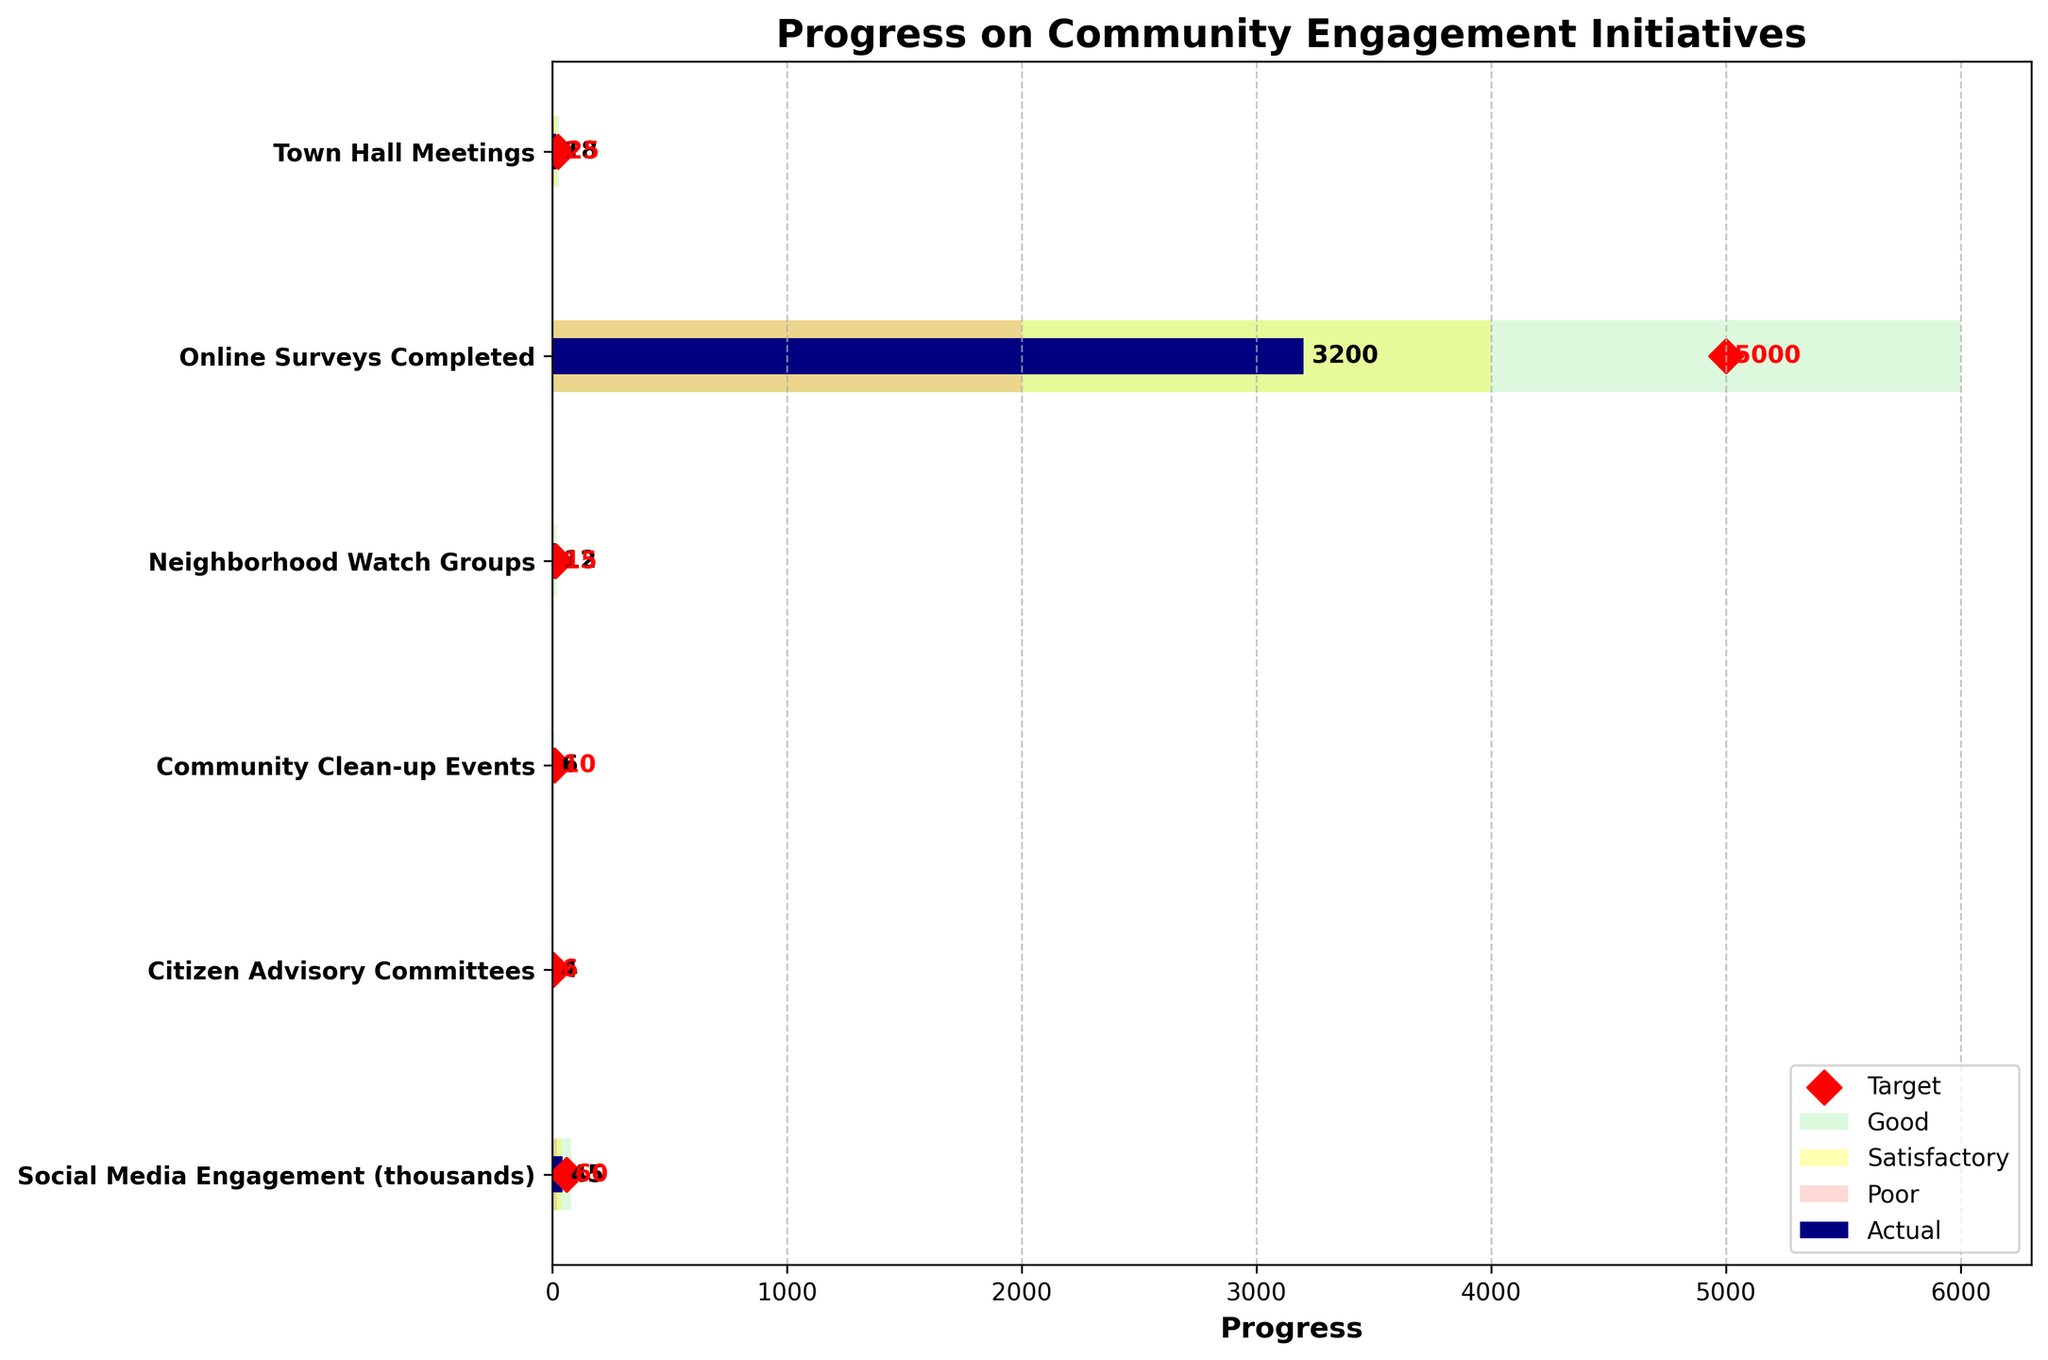What's the title of the chart, and what does it suggest? The title is "Progress on Community Engagement Initiatives", which indicates that the chart is tracking the progress of various community engagement efforts compared to their target goals.
Answer: "Progress on Community Engagement Initiatives" What is the 'Actual' number of Town Hall Meetings? The number of Town Hall Meetings is shown by the length of the navy bar corresponding to the 'Actual' column.
Answer: 18 What is the target value for Social Media Engagement? The target values in the chart are represented by red diamond markers. The red diamond for Social Media Engagement is at the 60 mark on the x-axis.
Answer: 60 Which initiative achieved the closest to its target goal? Comparing the lengths of the navy 'Actual' bars to the positions of the red diamond 'Target' markers reveals that Community Clean-up Events (6 actual vs. 10 target), with a small gap in-between, achieved closest to its target goal.
Answer: Community Clean-up Events How many Citizen Advisory Committees were actually formed, and how does this compare to the target? The number of Citizen Advisory Committees actually formed is indicated by the length of the navy bar, showing 4, while the red diamond marker shows a target of 6.
Answer: 4 actual, 6 target Which initiative was furthest from its target? By examining the difference between the 'Actual' and 'Target' markers, the Online Surveys Completed initiative (3200 actual vs. 5000 target) has the largest gap.
Answer: Online Surveys Completed What initiatives had 'Actual' values within the 'Satisfactory' range? The 'Satisfactory' range is shaded in yellow. Both Community Clean-up Events (6 within 6) and Citizen Advisory Committees (4 within 4-8) fall within this range.
Answer: Community Clean-up Events, Citizen Advisory Committees What percentage of the target did Neighborhood Watch Groups achieve? The 'Actual' value for Neighborhood Watch Groups is 12, and the target is 15. The percentage achievement is calculated as (12/15)*100.
Answer: 80% Which initiatives reached at least the 'Poor' range but less than 'Satisfactory'? The 'Poor' range is shaded in salmon. Town Hall Meetings (18 within 10-20) and Neighborhood Watch Groups (12 within 5-10) fit this criteria.
Answer: Town Hall Meetings, Neighborhood Watch Groups 